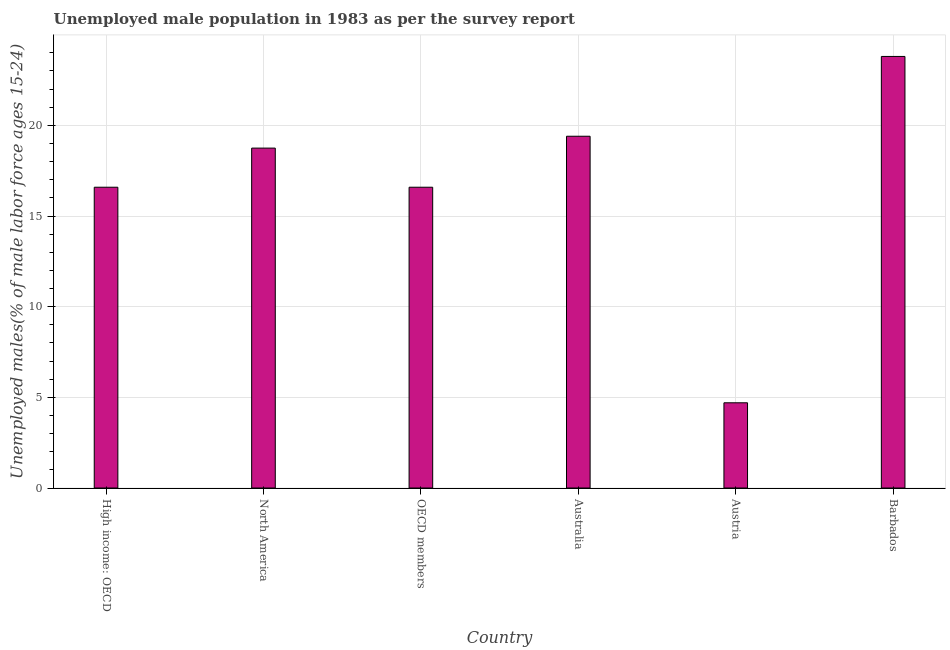What is the title of the graph?
Provide a succinct answer. Unemployed male population in 1983 as per the survey report. What is the label or title of the Y-axis?
Keep it short and to the point. Unemployed males(% of male labor force ages 15-24). What is the unemployed male youth in OECD members?
Ensure brevity in your answer.  16.59. Across all countries, what is the maximum unemployed male youth?
Offer a terse response. 23.8. Across all countries, what is the minimum unemployed male youth?
Provide a succinct answer. 4.7. In which country was the unemployed male youth maximum?
Offer a terse response. Barbados. What is the sum of the unemployed male youth?
Your answer should be very brief. 99.82. What is the difference between the unemployed male youth in High income: OECD and North America?
Your answer should be very brief. -2.16. What is the average unemployed male youth per country?
Offer a terse response. 16.64. What is the median unemployed male youth?
Give a very brief answer. 17.67. What is the ratio of the unemployed male youth in Australia to that in OECD members?
Give a very brief answer. 1.17. Is the sum of the unemployed male youth in Barbados and North America greater than the maximum unemployed male youth across all countries?
Your response must be concise. Yes. In how many countries, is the unemployed male youth greater than the average unemployed male youth taken over all countries?
Your response must be concise. 3. How many bars are there?
Make the answer very short. 6. How many countries are there in the graph?
Offer a terse response. 6. What is the difference between two consecutive major ticks on the Y-axis?
Your response must be concise. 5. What is the Unemployed males(% of male labor force ages 15-24) in High income: OECD?
Offer a very short reply. 16.59. What is the Unemployed males(% of male labor force ages 15-24) in North America?
Make the answer very short. 18.75. What is the Unemployed males(% of male labor force ages 15-24) of OECD members?
Keep it short and to the point. 16.59. What is the Unemployed males(% of male labor force ages 15-24) in Australia?
Offer a very short reply. 19.4. What is the Unemployed males(% of male labor force ages 15-24) in Austria?
Make the answer very short. 4.7. What is the Unemployed males(% of male labor force ages 15-24) of Barbados?
Your answer should be very brief. 23.8. What is the difference between the Unemployed males(% of male labor force ages 15-24) in High income: OECD and North America?
Your answer should be very brief. -2.16. What is the difference between the Unemployed males(% of male labor force ages 15-24) in High income: OECD and Australia?
Your answer should be very brief. -2.81. What is the difference between the Unemployed males(% of male labor force ages 15-24) in High income: OECD and Austria?
Offer a terse response. 11.89. What is the difference between the Unemployed males(% of male labor force ages 15-24) in High income: OECD and Barbados?
Ensure brevity in your answer.  -7.21. What is the difference between the Unemployed males(% of male labor force ages 15-24) in North America and OECD members?
Provide a short and direct response. 2.16. What is the difference between the Unemployed males(% of male labor force ages 15-24) in North America and Australia?
Your response must be concise. -0.65. What is the difference between the Unemployed males(% of male labor force ages 15-24) in North America and Austria?
Offer a terse response. 14.05. What is the difference between the Unemployed males(% of male labor force ages 15-24) in North America and Barbados?
Ensure brevity in your answer.  -5.05. What is the difference between the Unemployed males(% of male labor force ages 15-24) in OECD members and Australia?
Provide a short and direct response. -2.81. What is the difference between the Unemployed males(% of male labor force ages 15-24) in OECD members and Austria?
Provide a succinct answer. 11.89. What is the difference between the Unemployed males(% of male labor force ages 15-24) in OECD members and Barbados?
Your answer should be compact. -7.21. What is the difference between the Unemployed males(% of male labor force ages 15-24) in Austria and Barbados?
Give a very brief answer. -19.1. What is the ratio of the Unemployed males(% of male labor force ages 15-24) in High income: OECD to that in North America?
Give a very brief answer. 0.89. What is the ratio of the Unemployed males(% of male labor force ages 15-24) in High income: OECD to that in Australia?
Provide a succinct answer. 0.85. What is the ratio of the Unemployed males(% of male labor force ages 15-24) in High income: OECD to that in Austria?
Offer a very short reply. 3.53. What is the ratio of the Unemployed males(% of male labor force ages 15-24) in High income: OECD to that in Barbados?
Make the answer very short. 0.7. What is the ratio of the Unemployed males(% of male labor force ages 15-24) in North America to that in OECD members?
Your answer should be compact. 1.13. What is the ratio of the Unemployed males(% of male labor force ages 15-24) in North America to that in Austria?
Make the answer very short. 3.99. What is the ratio of the Unemployed males(% of male labor force ages 15-24) in North America to that in Barbados?
Offer a terse response. 0.79. What is the ratio of the Unemployed males(% of male labor force ages 15-24) in OECD members to that in Australia?
Keep it short and to the point. 0.85. What is the ratio of the Unemployed males(% of male labor force ages 15-24) in OECD members to that in Austria?
Make the answer very short. 3.53. What is the ratio of the Unemployed males(% of male labor force ages 15-24) in OECD members to that in Barbados?
Offer a very short reply. 0.7. What is the ratio of the Unemployed males(% of male labor force ages 15-24) in Australia to that in Austria?
Provide a succinct answer. 4.13. What is the ratio of the Unemployed males(% of male labor force ages 15-24) in Australia to that in Barbados?
Your response must be concise. 0.81. What is the ratio of the Unemployed males(% of male labor force ages 15-24) in Austria to that in Barbados?
Give a very brief answer. 0.2. 